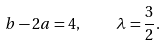<formula> <loc_0><loc_0><loc_500><loc_500>b - 2 a = 4 , \quad \lambda = \frac { 3 } { 2 } .</formula> 